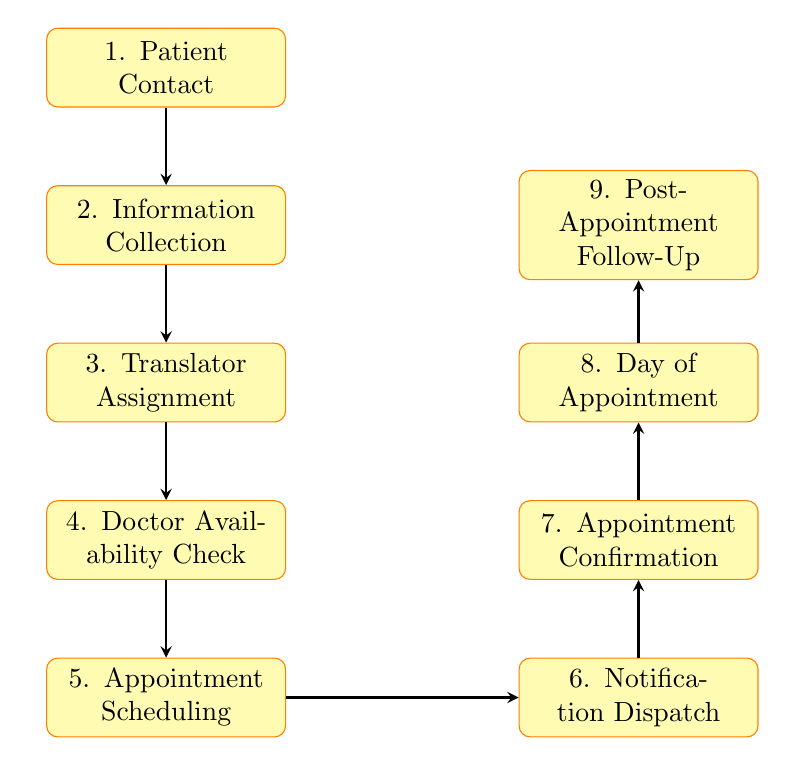What is the first step in the patient appointment scheduling process? The first step in the flow chart is labeled "1. Patient Contact," indicating that the patient's initial contact starts the process.
Answer: Patient Contact How many nodes are present in the diagram? The flow chart consists of nine nodes detailing various steps in the patient appointment scheduling process.
Answer: Nine Which step follows 'Doctor Availability Check'? The diagram shows that the step following 'Doctor Availability Check' is 'Appointment Scheduling,' indicating the next action taken after checking availability.
Answer: Appointment Scheduling What is the purpose of 'Translator Assignment'? 'Translator Assignment' serves to ensure that a suitable medical translator is assigned based on the patient's language preferences and medical needs, as indicated by its description in the diagram.
Answer: Assign a suitable medical translator What is the last step shown in the flow chart? The last step in the flow chart is 'Post-Appointment Follow-Up,' illustrating that the process concludes with feedback collection and communication after the appointment.
Answer: Post-Appointment Follow-Up What is the relationship between 'Notification Dispatch' and 'Appointment Confirmation'? The flow chart indicates that 'Notification Dispatch' occurs before 'Appointment Confirmation,' meaning notifications are sent out prior to confirming the appointment with all parties involved.
Answer: Notification Dispatch occurs before Appointment Confirmation What are the communication methods preferred for dispatching notifications? The flow chart description for 'Notification Dispatch' states that notifications are sent via the preferred communication method of the patient and translator, highlighting the customization in communication preferences.
Answer: Preferred communication method What is verified right after 'Information Collection'? After 'Information Collection', the diagram specifies that 'Translator Assignment' is the subsequent step, indicating the assignment of a translator based on the collected information.
Answer: Translator Assignment During what step does the patient receive confirmation of their appointment? The 'Appointment Confirmation' step is when the patient, translator, and doctor receive confirmation that the appointment has been successfully booked, as shown in the flow chart.
Answer: Appointment Confirmation 